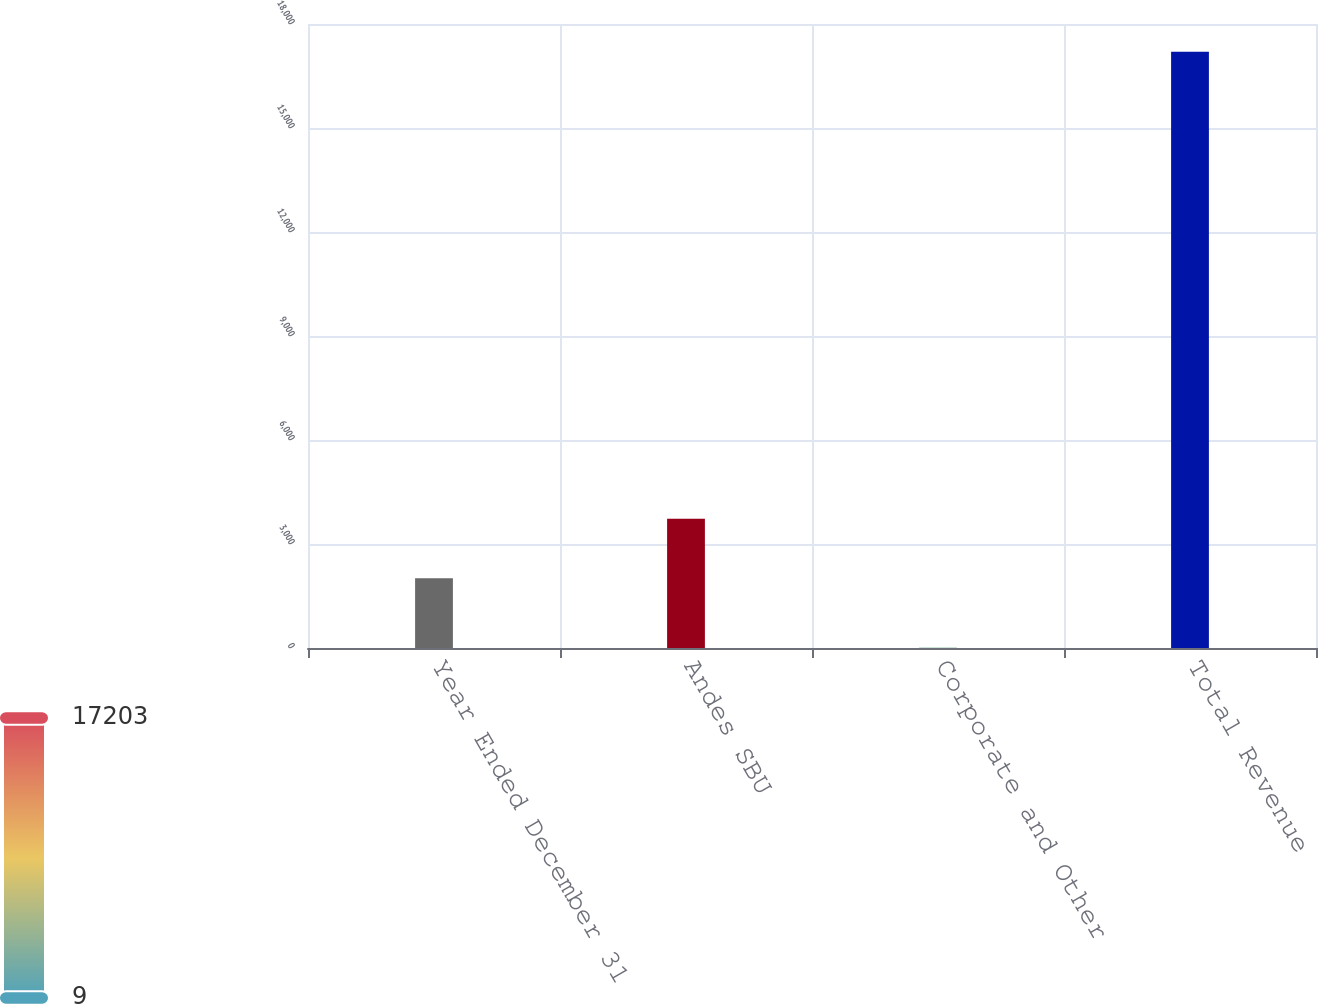Convert chart to OTSL. <chart><loc_0><loc_0><loc_500><loc_500><bar_chart><fcel>Year Ended December 31<fcel>Andes SBU<fcel>Corporate and Other<fcel>Total Revenue<nl><fcel>2012<fcel>3731.4<fcel>9<fcel>17203<nl></chart> 